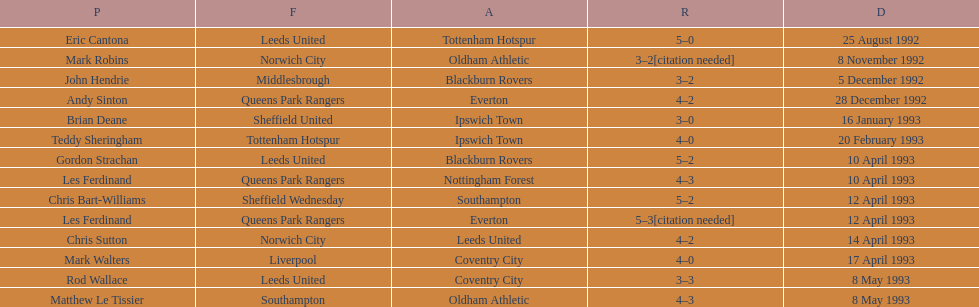Who does john hendrie play for? Middlesbrough. 